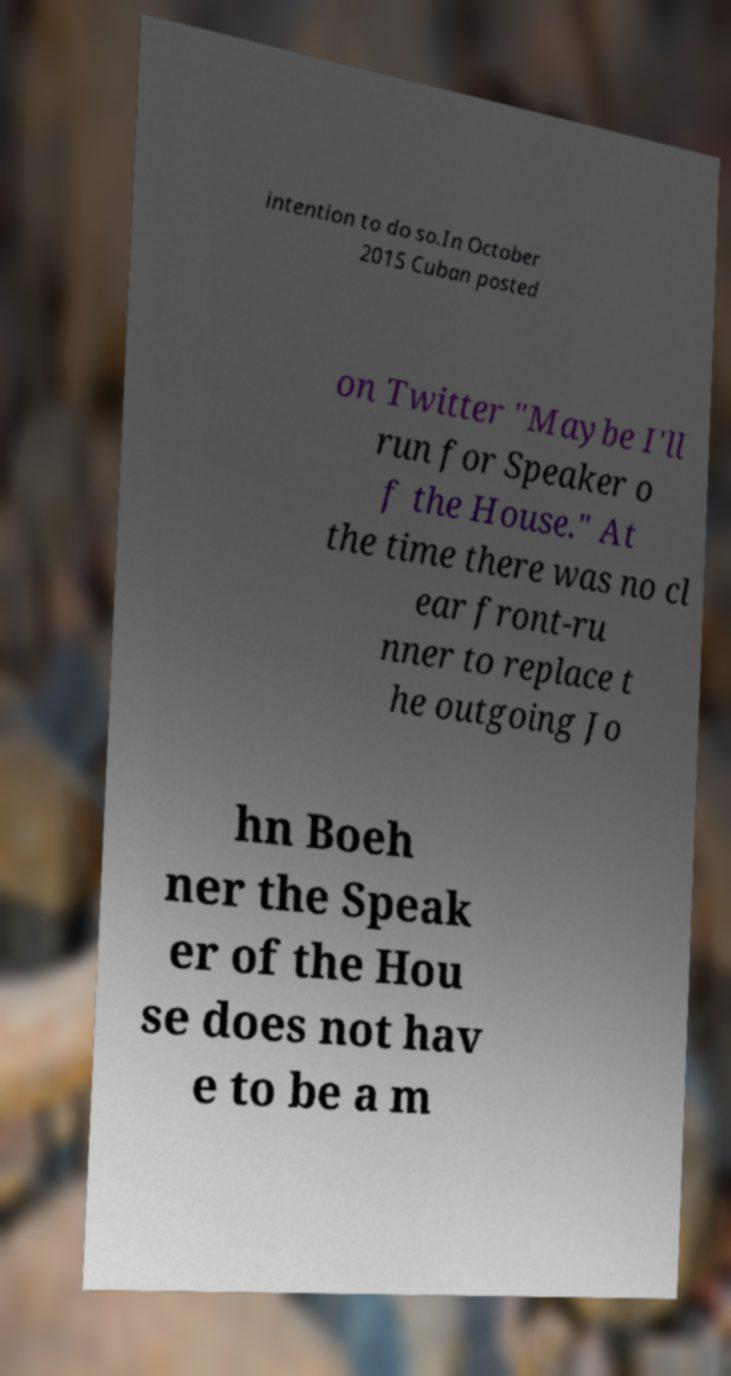Could you extract and type out the text from this image? intention to do so.In October 2015 Cuban posted on Twitter "Maybe I'll run for Speaker o f the House." At the time there was no cl ear front-ru nner to replace t he outgoing Jo hn Boeh ner the Speak er of the Hou se does not hav e to be a m 